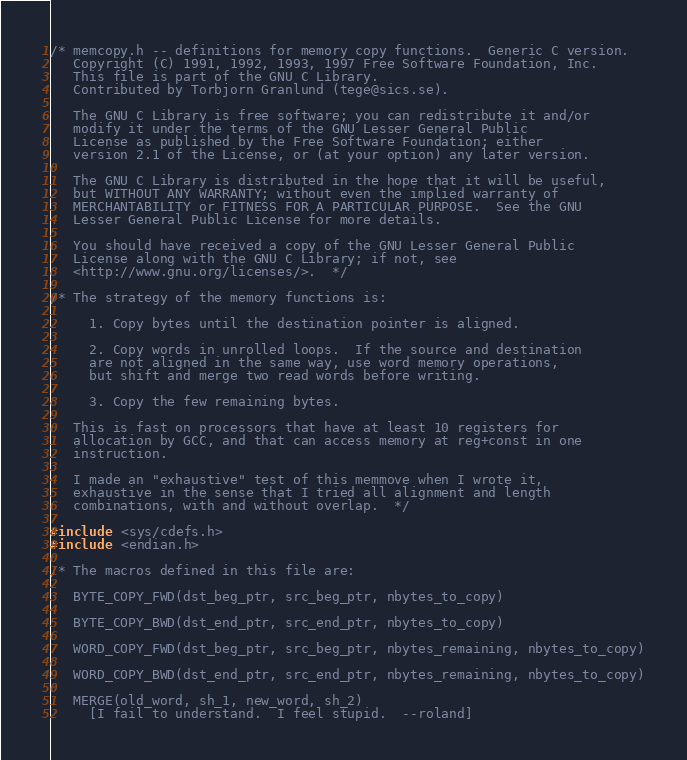Convert code to text. <code><loc_0><loc_0><loc_500><loc_500><_C_>/* memcopy.h -- definitions for memory copy functions.  Generic C version.
   Copyright (C) 1991, 1992, 1993, 1997 Free Software Foundation, Inc.
   This file is part of the GNU C Library.
   Contributed by Torbjorn Granlund (tege@sics.se).

   The GNU C Library is free software; you can redistribute it and/or
   modify it under the terms of the GNU Lesser General Public
   License as published by the Free Software Foundation; either
   version 2.1 of the License, or (at your option) any later version.

   The GNU C Library is distributed in the hope that it will be useful,
   but WITHOUT ANY WARRANTY; without even the implied warranty of
   MERCHANTABILITY or FITNESS FOR A PARTICULAR PURPOSE.  See the GNU
   Lesser General Public License for more details.

   You should have received a copy of the GNU Lesser General Public
   License along with the GNU C Library; if not, see
   <http://www.gnu.org/licenses/>.  */

/* The strategy of the memory functions is:

     1. Copy bytes until the destination pointer is aligned.

     2. Copy words in unrolled loops.  If the source and destination
     are not aligned in the same way, use word memory operations,
     but shift and merge two read words before writing.

     3. Copy the few remaining bytes.

   This is fast on processors that have at least 10 registers for
   allocation by GCC, and that can access memory at reg+const in one
   instruction.

   I made an "exhaustive" test of this memmove when I wrote it,
   exhaustive in the sense that I tried all alignment and length
   combinations, with and without overlap.  */

#include <sys/cdefs.h>
#include <endian.h>

/* The macros defined in this file are:

   BYTE_COPY_FWD(dst_beg_ptr, src_beg_ptr, nbytes_to_copy)

   BYTE_COPY_BWD(dst_end_ptr, src_end_ptr, nbytes_to_copy)

   WORD_COPY_FWD(dst_beg_ptr, src_beg_ptr, nbytes_remaining, nbytes_to_copy)

   WORD_COPY_BWD(dst_end_ptr, src_end_ptr, nbytes_remaining, nbytes_to_copy)

   MERGE(old_word, sh_1, new_word, sh_2)
     [I fail to understand.  I feel stupid.  --roland]</code> 